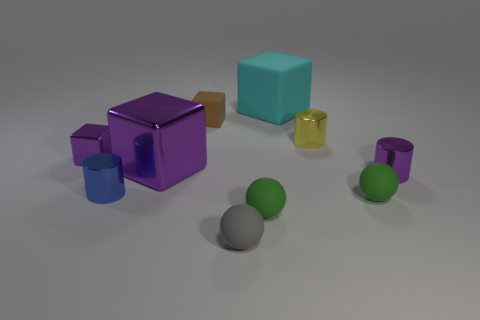The large thing that is left of the gray object is what color?
Offer a terse response. Purple. What number of other objects are the same color as the tiny rubber block?
Offer a very short reply. 0. Does the green rubber thing to the left of the cyan object have the same size as the small brown rubber cube?
Your answer should be compact. Yes. What number of yellow shiny objects are left of the large cyan rubber block?
Your response must be concise. 0. Is there a green rubber thing of the same size as the blue object?
Offer a very short reply. Yes. Is the color of the small metallic cube the same as the large metal block?
Keep it short and to the point. Yes. What is the color of the small block that is right of the purple metal cube to the left of the blue cylinder?
Make the answer very short. Brown. How many tiny objects are on the left side of the small purple metallic cylinder and to the right of the yellow metal cylinder?
Offer a very short reply. 1. What number of small gray objects are the same shape as the small blue object?
Ensure brevity in your answer.  0. Do the tiny brown block and the yellow cylinder have the same material?
Keep it short and to the point. No. 